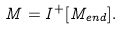<formula> <loc_0><loc_0><loc_500><loc_500>M = I ^ { + } [ M _ { e n d } ] .</formula> 